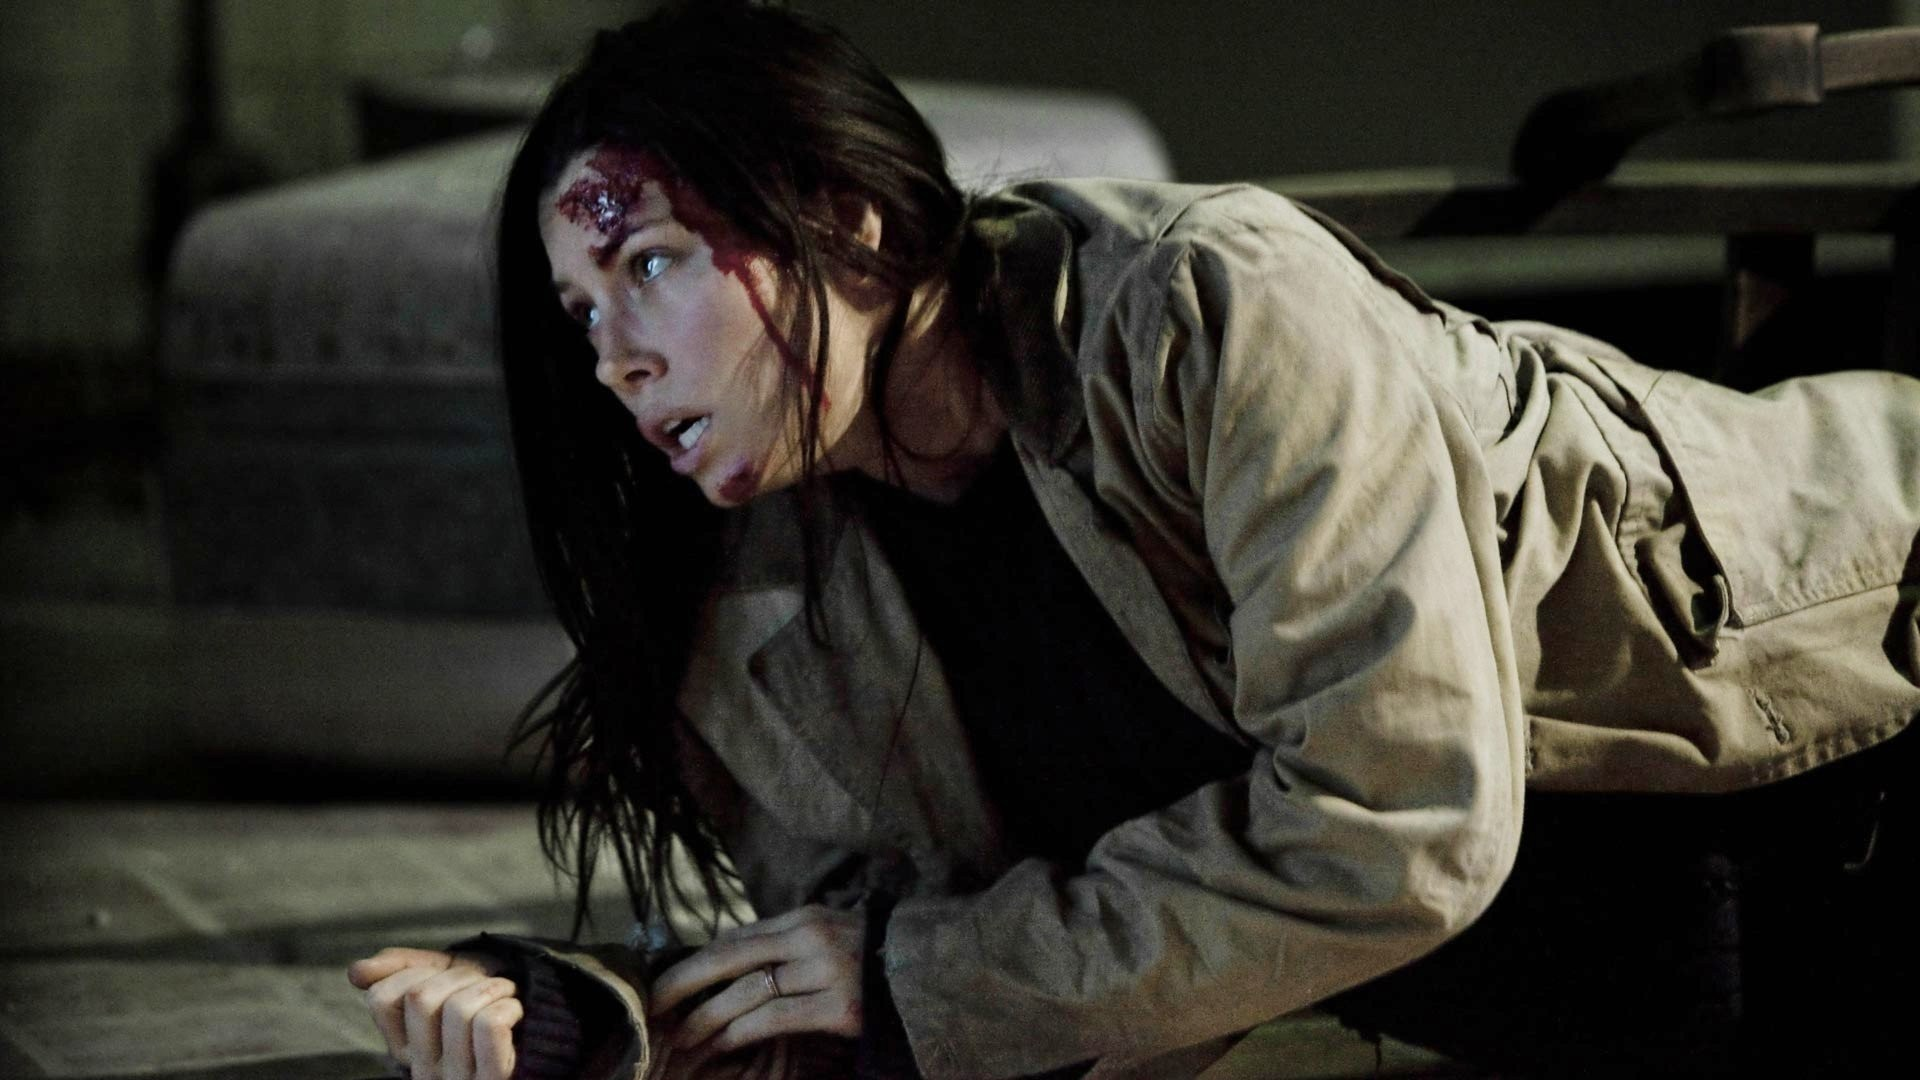If this image is part of a post-apocalyptic film, what role does she play in the storyline? In a post-apocalyptic film, the woman in the image might be a survivor scavenging for resources in abandoned buildings. The warehouse she is in could be one of the many derelict places she explores in search of food, water, and shelter. The wound on her forehead hints at the harsh and dangerous lifestyle she leads, facing bandits or wild animals frequently. Her crawling suggests she's either hiding from immediate danger or too exhausted and injured to move quickly. Her role might be that of a leader or a key member in a small group of survivors, determined to navigate through the remnants of civilization while clinging to hope for rebuilding society. Describe her journey back to her group's hideout in a short narrative. The woman, hurt and on the brink of collapse, musters the last of her strength to crawl out of the warehouse. Through the dimly lit ruins of the city, she stays hidden in the shadows to avoid roaming threats. Every step is a struggle, but the thought of her group's hideout fuels her willpower. Finally, she reaches the underground bunker that is their safe haven. Her fellow survivors rush to her aid, their faces lighting up with relief as they pull her to safety. 